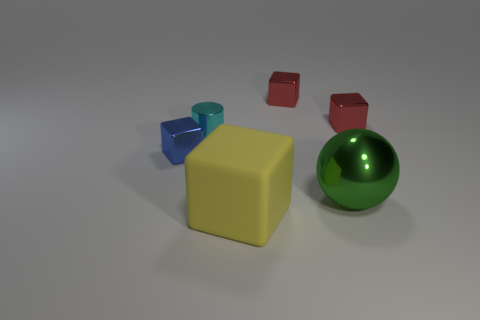Are there any other things that are the same size as the yellow cube?
Your answer should be compact. Yes. There is a green sphere; how many spheres are behind it?
Give a very brief answer. 0. Is the number of big things in front of the big yellow matte block the same as the number of tiny blue things?
Make the answer very short. No. What number of objects are blue metallic things or yellow cubes?
Ensure brevity in your answer.  2. Is there anything else that has the same shape as the matte thing?
Make the answer very short. Yes. The big thing on the right side of the yellow object in front of the cyan metallic object is what shape?
Ensure brevity in your answer.  Sphere. What is the shape of the blue thing that is the same material as the tiny cylinder?
Your response must be concise. Cube. What is the size of the thing to the right of the metal object that is in front of the tiny blue metallic object?
Provide a short and direct response. Small. What is the shape of the large green object?
Make the answer very short. Sphere. What number of tiny things are blocks or blue objects?
Make the answer very short. 3. 